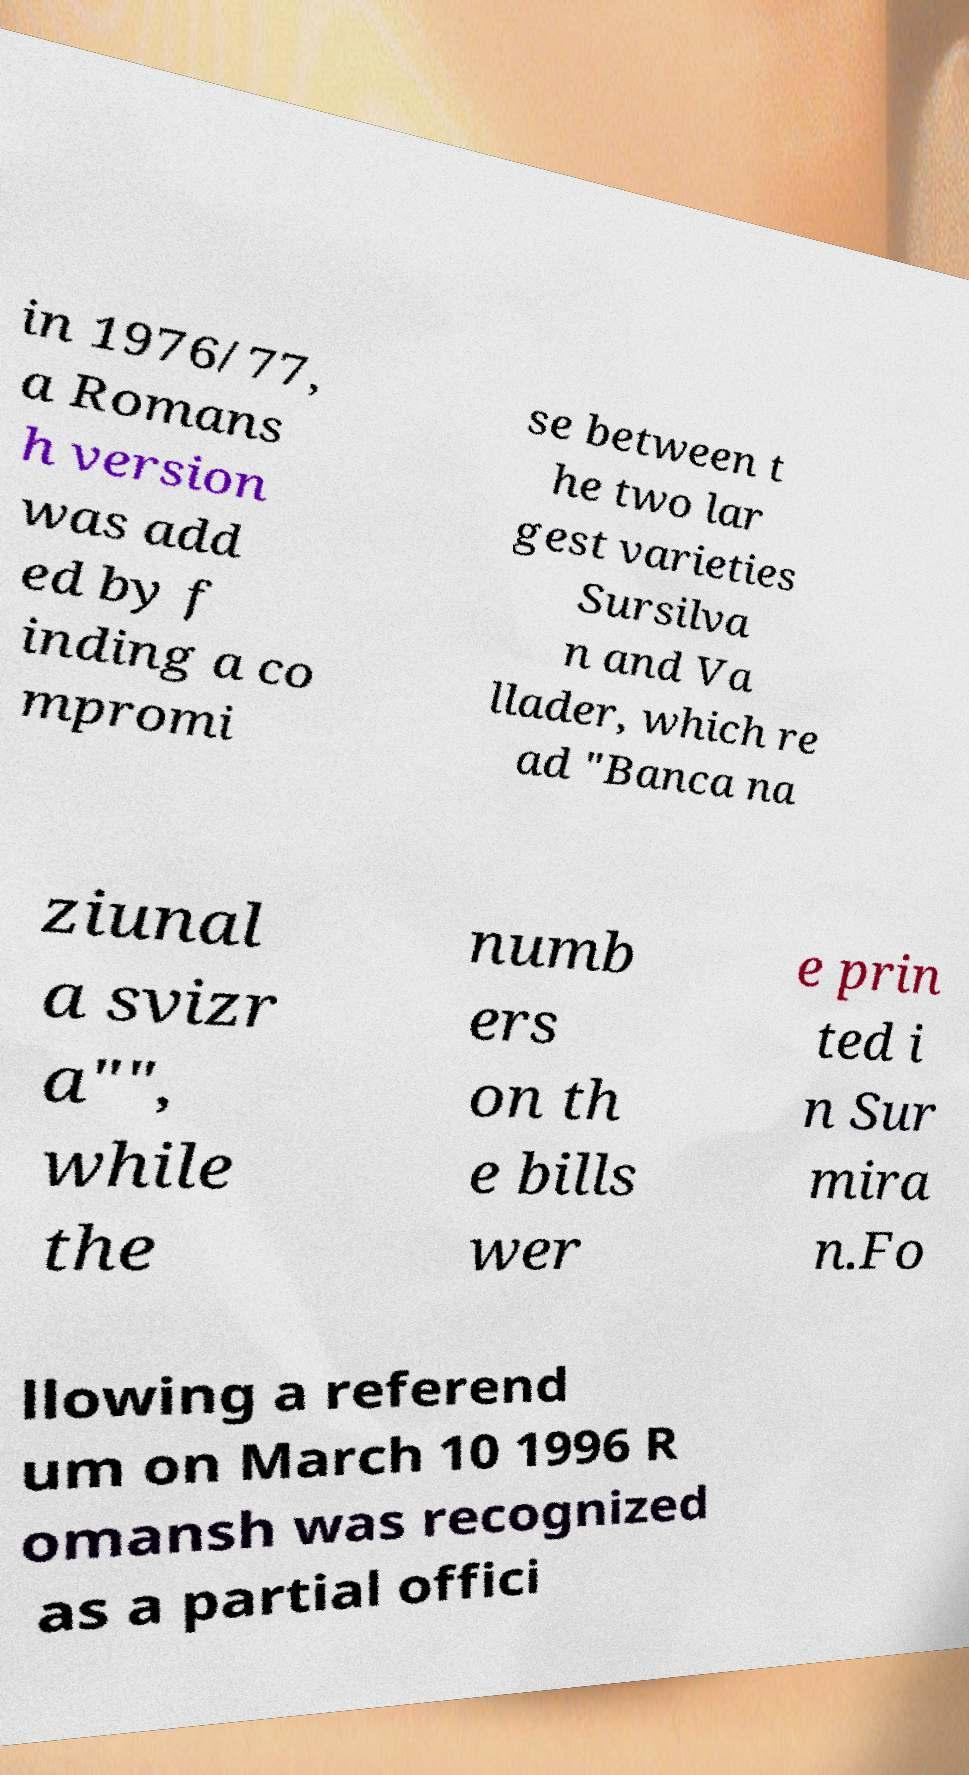Could you assist in decoding the text presented in this image and type it out clearly? in 1976/77, a Romans h version was add ed by f inding a co mpromi se between t he two lar gest varieties Sursilva n and Va llader, which re ad "Banca na ziunal a svizr a"", while the numb ers on th e bills wer e prin ted i n Sur mira n.Fo llowing a referend um on March 10 1996 R omansh was recognized as a partial offici 